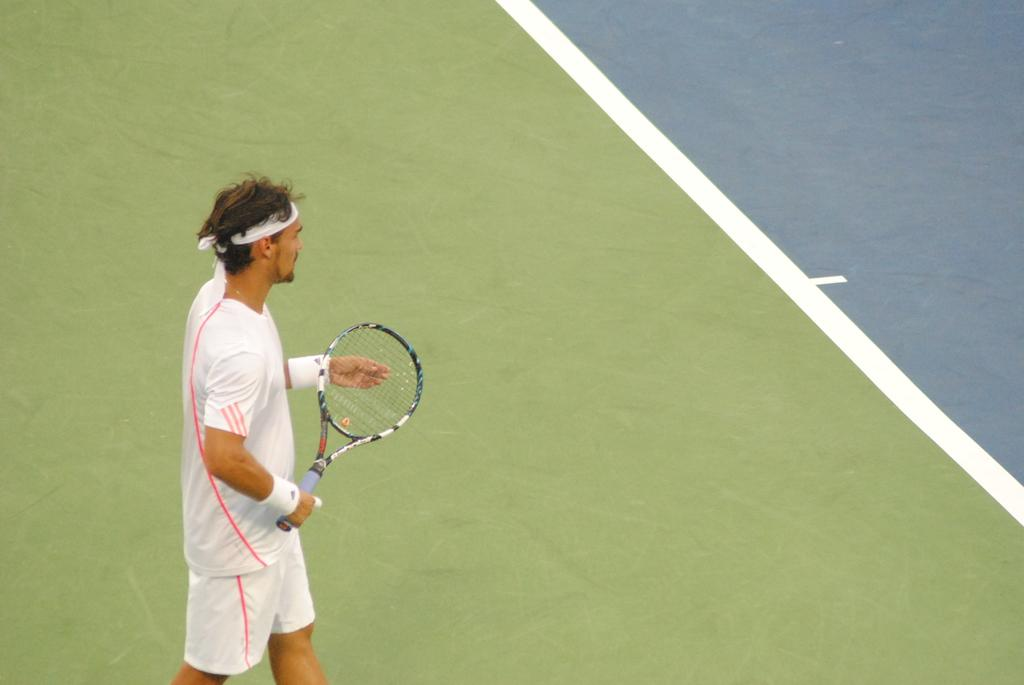Who is present in the image? There is a man in the image. What is the man doing in the image? The man is standing in the image. What object is the man holding in the image? The man is holding a racket in the image. What can be seen in the background of the image? There is a ground visible in the background of the image. What type of rifle can be seen in the man's hand in the image? There is no rifle present in the image; the man is holding a racket. How many cars are visible in the image? There are no cars visible in the image. 